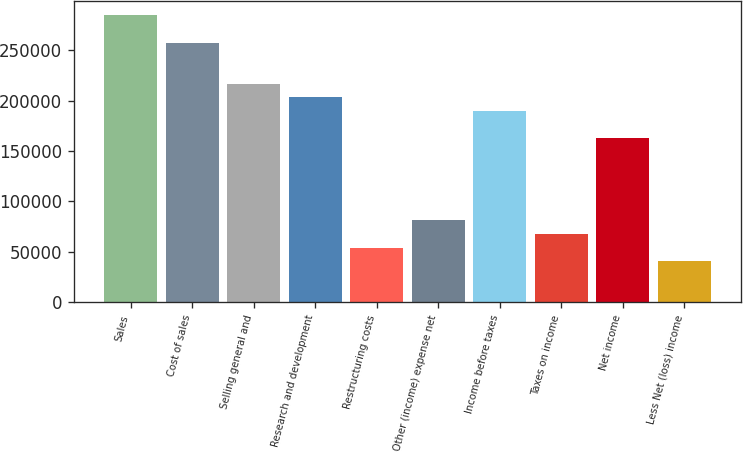Convert chart to OTSL. <chart><loc_0><loc_0><loc_500><loc_500><bar_chart><fcel>Sales<fcel>Cost of sales<fcel>Selling general and<fcel>Research and development<fcel>Restructuring costs<fcel>Other (income) expense net<fcel>Income before taxes<fcel>Taxes on income<fcel>Net income<fcel>Less Net (loss) income<nl><fcel>284548<fcel>257449<fcel>216799<fcel>203249<fcel>54200.9<fcel>81300.6<fcel>189699<fcel>67750.8<fcel>162600<fcel>40651.1<nl></chart> 